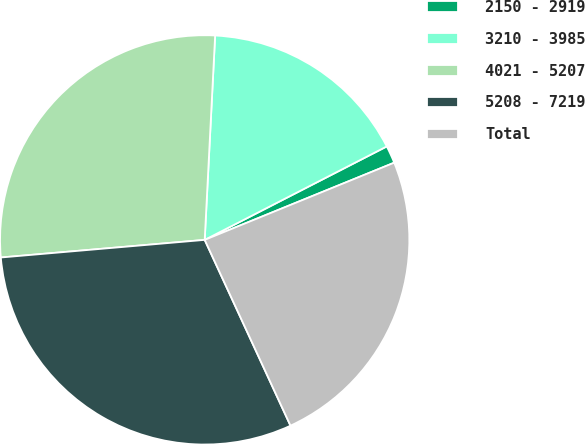<chart> <loc_0><loc_0><loc_500><loc_500><pie_chart><fcel>2150 - 2919<fcel>3210 - 3985<fcel>4021 - 5207<fcel>5208 - 7219<fcel>Total<nl><fcel>1.39%<fcel>16.64%<fcel>27.18%<fcel>30.51%<fcel>24.27%<nl></chart> 